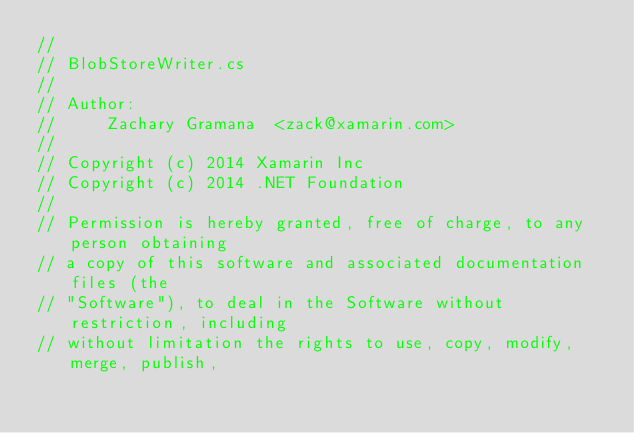<code> <loc_0><loc_0><loc_500><loc_500><_C#_>//
// BlobStoreWriter.cs
//
// Author:
//     Zachary Gramana  <zack@xamarin.com>
//
// Copyright (c) 2014 Xamarin Inc
// Copyright (c) 2014 .NET Foundation
//
// Permission is hereby granted, free of charge, to any person obtaining
// a copy of this software and associated documentation files (the
// "Software"), to deal in the Software without restriction, including
// without limitation the rights to use, copy, modify, merge, publish,</code> 